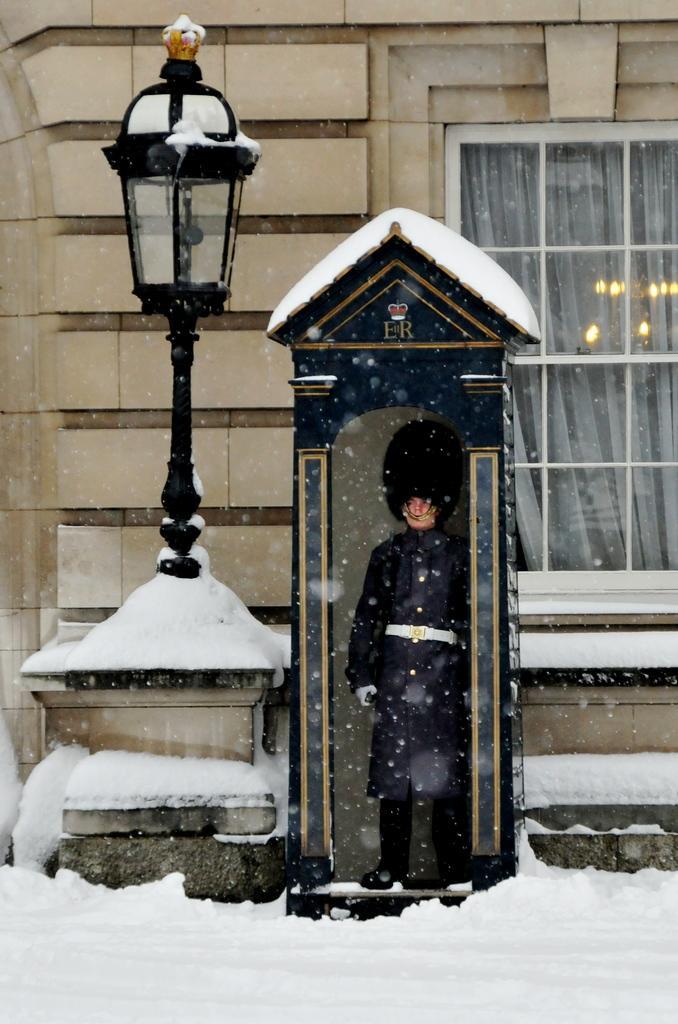Describe this image in one or two sentences. At the bottom of the image there is snow. And there is a small room with roof. Inside the room there is a person standing. Beside the room there is a pole with lamp. In the background there is a wall with glass window. Inside the window there is a curtain and also there are lights. 